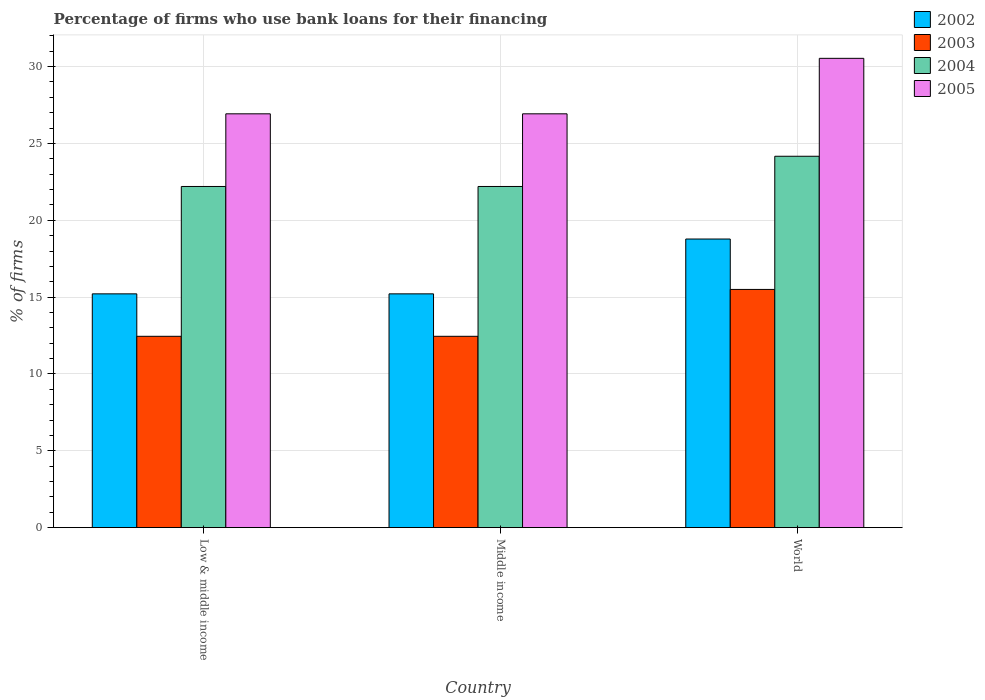How many different coloured bars are there?
Give a very brief answer. 4. Are the number of bars on each tick of the X-axis equal?
Keep it short and to the point. Yes. How many bars are there on the 2nd tick from the right?
Your answer should be compact. 4. In how many cases, is the number of bars for a given country not equal to the number of legend labels?
Provide a succinct answer. 0. What is the percentage of firms who use bank loans for their financing in 2005 in Low & middle income?
Make the answer very short. 26.93. Across all countries, what is the maximum percentage of firms who use bank loans for their financing in 2005?
Provide a succinct answer. 30.54. In which country was the percentage of firms who use bank loans for their financing in 2003 maximum?
Give a very brief answer. World. In which country was the percentage of firms who use bank loans for their financing in 2002 minimum?
Provide a short and direct response. Low & middle income. What is the total percentage of firms who use bank loans for their financing in 2005 in the graph?
Your answer should be compact. 84.39. What is the difference between the percentage of firms who use bank loans for their financing in 2003 in Middle income and that in World?
Ensure brevity in your answer.  -3.05. What is the difference between the percentage of firms who use bank loans for their financing in 2002 in Middle income and the percentage of firms who use bank loans for their financing in 2005 in Low & middle income?
Ensure brevity in your answer.  -11.72. What is the average percentage of firms who use bank loans for their financing in 2003 per country?
Offer a terse response. 13.47. What is the difference between the percentage of firms who use bank loans for their financing of/in 2002 and percentage of firms who use bank loans for their financing of/in 2005 in World?
Your response must be concise. -11.76. What is the ratio of the percentage of firms who use bank loans for their financing in 2004 in Low & middle income to that in World?
Offer a terse response. 0.92. Is the percentage of firms who use bank loans for their financing in 2002 in Low & middle income less than that in World?
Your answer should be compact. Yes. Is the difference between the percentage of firms who use bank loans for their financing in 2002 in Low & middle income and World greater than the difference between the percentage of firms who use bank loans for their financing in 2005 in Low & middle income and World?
Keep it short and to the point. Yes. What is the difference between the highest and the second highest percentage of firms who use bank loans for their financing in 2003?
Provide a succinct answer. -3.05. What is the difference between the highest and the lowest percentage of firms who use bank loans for their financing in 2005?
Make the answer very short. 3.61. Is the sum of the percentage of firms who use bank loans for their financing in 2003 in Low & middle income and Middle income greater than the maximum percentage of firms who use bank loans for their financing in 2004 across all countries?
Provide a succinct answer. Yes. Is it the case that in every country, the sum of the percentage of firms who use bank loans for their financing in 2004 and percentage of firms who use bank loans for their financing in 2003 is greater than the sum of percentage of firms who use bank loans for their financing in 2002 and percentage of firms who use bank loans for their financing in 2005?
Give a very brief answer. No. What does the 4th bar from the left in World represents?
Your answer should be very brief. 2005. How many bars are there?
Make the answer very short. 12. Are all the bars in the graph horizontal?
Make the answer very short. No. Are the values on the major ticks of Y-axis written in scientific E-notation?
Your answer should be compact. No. Does the graph contain any zero values?
Make the answer very short. No. Does the graph contain grids?
Your answer should be very brief. Yes. How are the legend labels stacked?
Offer a terse response. Vertical. What is the title of the graph?
Provide a short and direct response. Percentage of firms who use bank loans for their financing. Does "1970" appear as one of the legend labels in the graph?
Make the answer very short. No. What is the label or title of the Y-axis?
Keep it short and to the point. % of firms. What is the % of firms in 2002 in Low & middle income?
Your response must be concise. 15.21. What is the % of firms in 2003 in Low & middle income?
Offer a terse response. 12.45. What is the % of firms of 2005 in Low & middle income?
Your answer should be very brief. 26.93. What is the % of firms in 2002 in Middle income?
Provide a succinct answer. 15.21. What is the % of firms of 2003 in Middle income?
Provide a succinct answer. 12.45. What is the % of firms in 2004 in Middle income?
Give a very brief answer. 22.2. What is the % of firms in 2005 in Middle income?
Offer a terse response. 26.93. What is the % of firms in 2002 in World?
Ensure brevity in your answer.  18.78. What is the % of firms in 2003 in World?
Offer a very short reply. 15.5. What is the % of firms of 2004 in World?
Ensure brevity in your answer.  24.17. What is the % of firms of 2005 in World?
Provide a short and direct response. 30.54. Across all countries, what is the maximum % of firms of 2002?
Ensure brevity in your answer.  18.78. Across all countries, what is the maximum % of firms in 2003?
Offer a terse response. 15.5. Across all countries, what is the maximum % of firms in 2004?
Give a very brief answer. 24.17. Across all countries, what is the maximum % of firms of 2005?
Keep it short and to the point. 30.54. Across all countries, what is the minimum % of firms of 2002?
Ensure brevity in your answer.  15.21. Across all countries, what is the minimum % of firms of 2003?
Provide a succinct answer. 12.45. Across all countries, what is the minimum % of firms of 2005?
Your response must be concise. 26.93. What is the total % of firms of 2002 in the graph?
Make the answer very short. 49.21. What is the total % of firms in 2003 in the graph?
Provide a succinct answer. 40.4. What is the total % of firms in 2004 in the graph?
Provide a short and direct response. 68.57. What is the total % of firms of 2005 in the graph?
Your answer should be compact. 84.39. What is the difference between the % of firms of 2003 in Low & middle income and that in Middle income?
Your answer should be compact. 0. What is the difference between the % of firms of 2005 in Low & middle income and that in Middle income?
Offer a terse response. 0. What is the difference between the % of firms in 2002 in Low & middle income and that in World?
Your answer should be compact. -3.57. What is the difference between the % of firms of 2003 in Low & middle income and that in World?
Offer a terse response. -3.05. What is the difference between the % of firms of 2004 in Low & middle income and that in World?
Provide a short and direct response. -1.97. What is the difference between the % of firms in 2005 in Low & middle income and that in World?
Ensure brevity in your answer.  -3.61. What is the difference between the % of firms in 2002 in Middle income and that in World?
Make the answer very short. -3.57. What is the difference between the % of firms of 2003 in Middle income and that in World?
Your answer should be very brief. -3.05. What is the difference between the % of firms of 2004 in Middle income and that in World?
Your response must be concise. -1.97. What is the difference between the % of firms of 2005 in Middle income and that in World?
Give a very brief answer. -3.61. What is the difference between the % of firms of 2002 in Low & middle income and the % of firms of 2003 in Middle income?
Offer a terse response. 2.76. What is the difference between the % of firms of 2002 in Low & middle income and the % of firms of 2004 in Middle income?
Provide a succinct answer. -6.99. What is the difference between the % of firms in 2002 in Low & middle income and the % of firms in 2005 in Middle income?
Give a very brief answer. -11.72. What is the difference between the % of firms of 2003 in Low & middle income and the % of firms of 2004 in Middle income?
Offer a terse response. -9.75. What is the difference between the % of firms in 2003 in Low & middle income and the % of firms in 2005 in Middle income?
Keep it short and to the point. -14.48. What is the difference between the % of firms of 2004 in Low & middle income and the % of firms of 2005 in Middle income?
Provide a succinct answer. -4.73. What is the difference between the % of firms of 2002 in Low & middle income and the % of firms of 2003 in World?
Offer a very short reply. -0.29. What is the difference between the % of firms of 2002 in Low & middle income and the % of firms of 2004 in World?
Your response must be concise. -8.95. What is the difference between the % of firms of 2002 in Low & middle income and the % of firms of 2005 in World?
Your response must be concise. -15.33. What is the difference between the % of firms of 2003 in Low & middle income and the % of firms of 2004 in World?
Your answer should be compact. -11.72. What is the difference between the % of firms in 2003 in Low & middle income and the % of firms in 2005 in World?
Offer a very short reply. -18.09. What is the difference between the % of firms in 2004 in Low & middle income and the % of firms in 2005 in World?
Provide a succinct answer. -8.34. What is the difference between the % of firms in 2002 in Middle income and the % of firms in 2003 in World?
Give a very brief answer. -0.29. What is the difference between the % of firms in 2002 in Middle income and the % of firms in 2004 in World?
Your response must be concise. -8.95. What is the difference between the % of firms of 2002 in Middle income and the % of firms of 2005 in World?
Your answer should be very brief. -15.33. What is the difference between the % of firms in 2003 in Middle income and the % of firms in 2004 in World?
Keep it short and to the point. -11.72. What is the difference between the % of firms of 2003 in Middle income and the % of firms of 2005 in World?
Offer a very short reply. -18.09. What is the difference between the % of firms in 2004 in Middle income and the % of firms in 2005 in World?
Give a very brief answer. -8.34. What is the average % of firms in 2002 per country?
Make the answer very short. 16.4. What is the average % of firms in 2003 per country?
Give a very brief answer. 13.47. What is the average % of firms of 2004 per country?
Your answer should be very brief. 22.86. What is the average % of firms in 2005 per country?
Provide a succinct answer. 28.13. What is the difference between the % of firms of 2002 and % of firms of 2003 in Low & middle income?
Offer a very short reply. 2.76. What is the difference between the % of firms in 2002 and % of firms in 2004 in Low & middle income?
Give a very brief answer. -6.99. What is the difference between the % of firms of 2002 and % of firms of 2005 in Low & middle income?
Keep it short and to the point. -11.72. What is the difference between the % of firms in 2003 and % of firms in 2004 in Low & middle income?
Your answer should be very brief. -9.75. What is the difference between the % of firms of 2003 and % of firms of 2005 in Low & middle income?
Give a very brief answer. -14.48. What is the difference between the % of firms of 2004 and % of firms of 2005 in Low & middle income?
Your response must be concise. -4.73. What is the difference between the % of firms of 2002 and % of firms of 2003 in Middle income?
Keep it short and to the point. 2.76. What is the difference between the % of firms in 2002 and % of firms in 2004 in Middle income?
Ensure brevity in your answer.  -6.99. What is the difference between the % of firms of 2002 and % of firms of 2005 in Middle income?
Your answer should be compact. -11.72. What is the difference between the % of firms of 2003 and % of firms of 2004 in Middle income?
Your answer should be very brief. -9.75. What is the difference between the % of firms in 2003 and % of firms in 2005 in Middle income?
Provide a short and direct response. -14.48. What is the difference between the % of firms of 2004 and % of firms of 2005 in Middle income?
Keep it short and to the point. -4.73. What is the difference between the % of firms in 2002 and % of firms in 2003 in World?
Provide a short and direct response. 3.28. What is the difference between the % of firms of 2002 and % of firms of 2004 in World?
Make the answer very short. -5.39. What is the difference between the % of firms in 2002 and % of firms in 2005 in World?
Ensure brevity in your answer.  -11.76. What is the difference between the % of firms of 2003 and % of firms of 2004 in World?
Give a very brief answer. -8.67. What is the difference between the % of firms in 2003 and % of firms in 2005 in World?
Provide a short and direct response. -15.04. What is the difference between the % of firms of 2004 and % of firms of 2005 in World?
Keep it short and to the point. -6.37. What is the ratio of the % of firms in 2003 in Low & middle income to that in Middle income?
Ensure brevity in your answer.  1. What is the ratio of the % of firms in 2002 in Low & middle income to that in World?
Ensure brevity in your answer.  0.81. What is the ratio of the % of firms of 2003 in Low & middle income to that in World?
Provide a succinct answer. 0.8. What is the ratio of the % of firms of 2004 in Low & middle income to that in World?
Provide a short and direct response. 0.92. What is the ratio of the % of firms of 2005 in Low & middle income to that in World?
Your answer should be compact. 0.88. What is the ratio of the % of firms in 2002 in Middle income to that in World?
Provide a succinct answer. 0.81. What is the ratio of the % of firms of 2003 in Middle income to that in World?
Provide a succinct answer. 0.8. What is the ratio of the % of firms of 2004 in Middle income to that in World?
Keep it short and to the point. 0.92. What is the ratio of the % of firms in 2005 in Middle income to that in World?
Provide a short and direct response. 0.88. What is the difference between the highest and the second highest % of firms in 2002?
Offer a terse response. 3.57. What is the difference between the highest and the second highest % of firms of 2003?
Provide a succinct answer. 3.05. What is the difference between the highest and the second highest % of firms of 2004?
Your answer should be very brief. 1.97. What is the difference between the highest and the second highest % of firms of 2005?
Provide a short and direct response. 3.61. What is the difference between the highest and the lowest % of firms of 2002?
Ensure brevity in your answer.  3.57. What is the difference between the highest and the lowest % of firms in 2003?
Give a very brief answer. 3.05. What is the difference between the highest and the lowest % of firms of 2004?
Provide a short and direct response. 1.97. What is the difference between the highest and the lowest % of firms in 2005?
Your answer should be very brief. 3.61. 